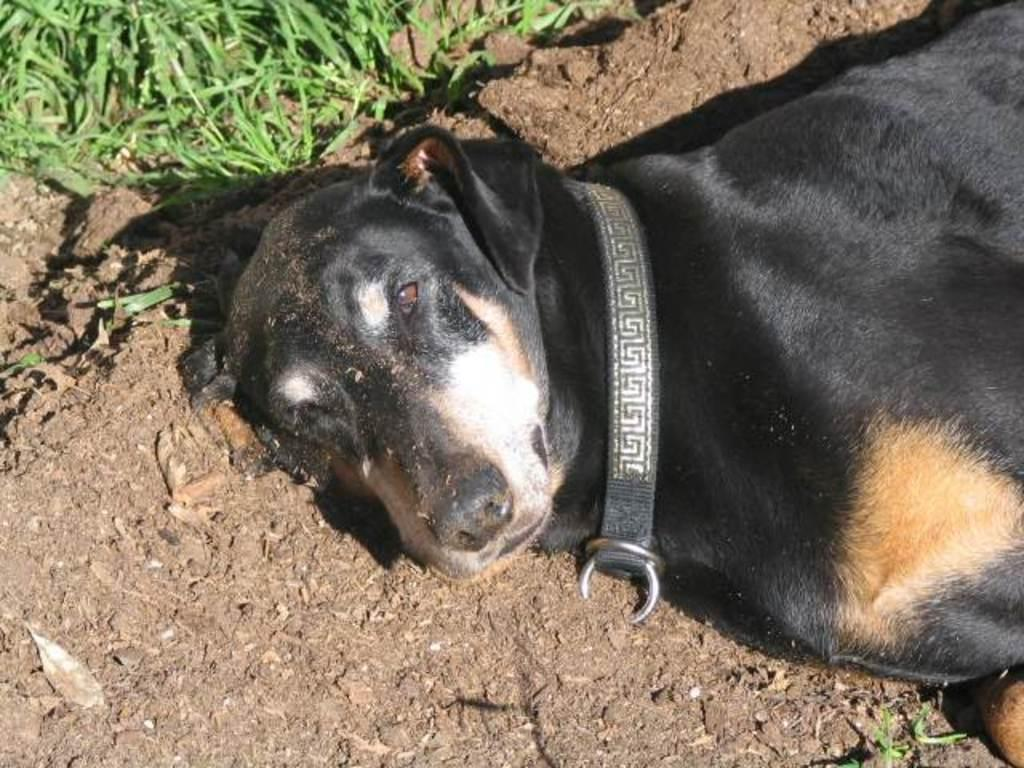What type of animal is in the image? There is a black dog in the image. What is the dog doing in the image? The dog is lying on the ground. What can be seen in the background of the image? There is grass visible in the background of the image. What flavor of cake is the dog eating in the image? There is no cake present in the image; the dog is lying on the ground. How does the dog use its hearing in the image? The image does not provide information about the dog's hearing or any related actions. 